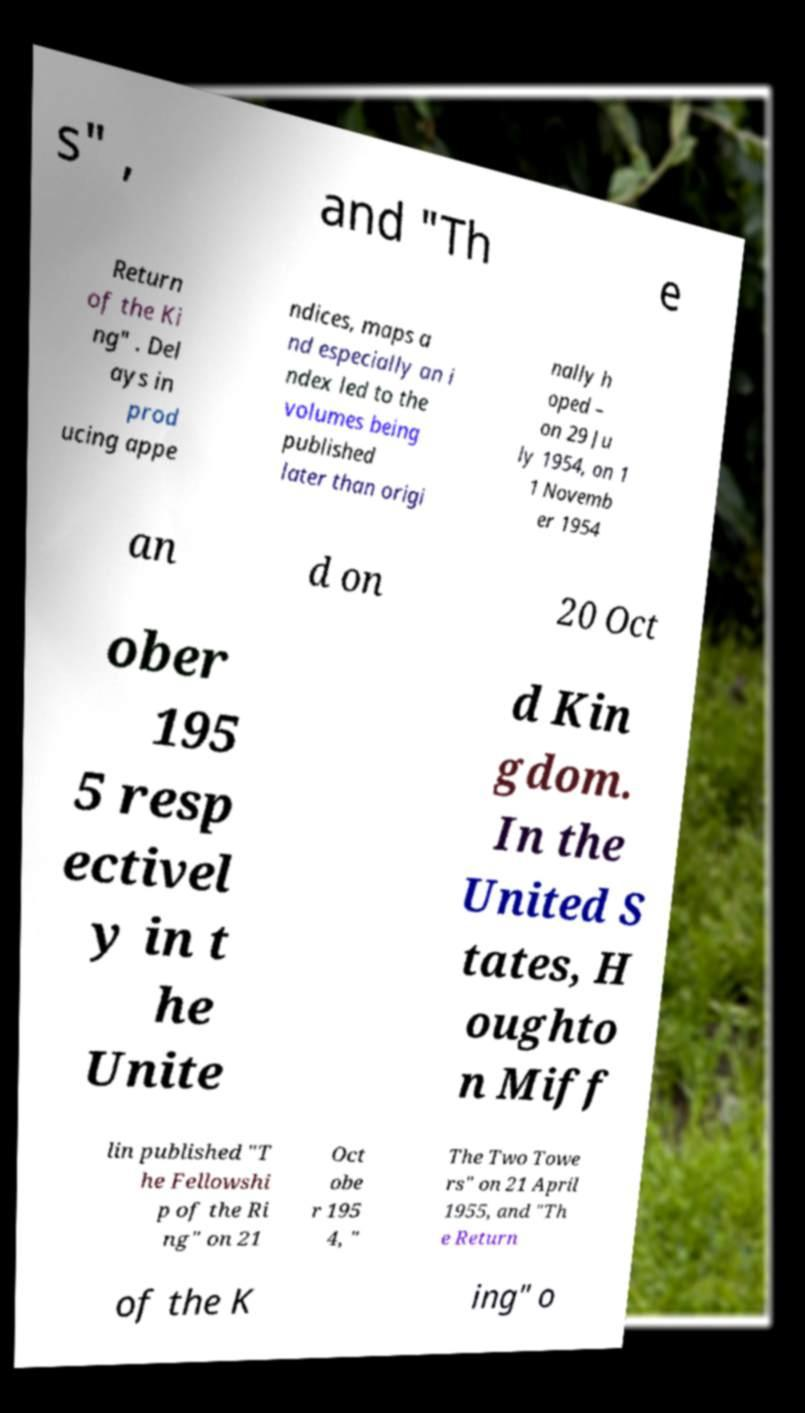Can you accurately transcribe the text from the provided image for me? s" , and "Th e Return of the Ki ng" . Del ays in prod ucing appe ndices, maps a nd especially an i ndex led to the volumes being published later than origi nally h oped – on 29 Ju ly 1954, on 1 1 Novemb er 1954 an d on 20 Oct ober 195 5 resp ectivel y in t he Unite d Kin gdom. In the United S tates, H oughto n Miff lin published "T he Fellowshi p of the Ri ng" on 21 Oct obe r 195 4, " The Two Towe rs" on 21 April 1955, and "Th e Return of the K ing" o 